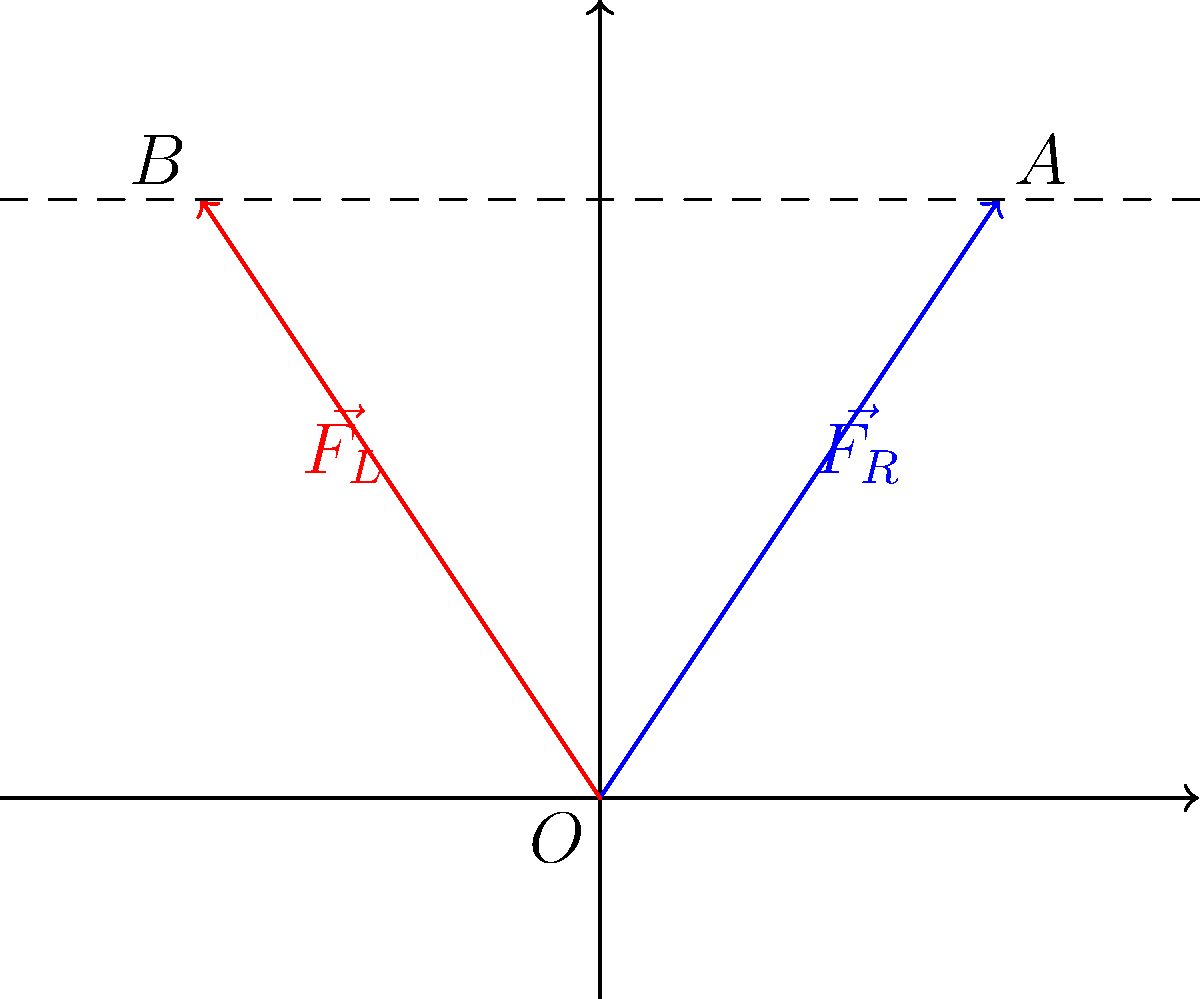In the diagram above, $\vec{F_R}$ represents the force vector for the right limb during a bilateral weightlifting movement, and $\vec{F_L}$ represents the force vector for the left limb. If $\vec{F_R}$ is reflected across the y-axis to create $\vec{F_L}$, what transformational geometry concept is demonstrated, and how does this reflection affect the magnitude and direction of the force vectors? To answer this question, let's analyze the transformational geometry concept and its effects on the force vectors:

1. Transformational Geometry Concept:
   The concept demonstrated here is reflection across the y-axis. This is a type of isometric transformation, which preserves the size and shape of the original object.

2. Effect on Magnitude:
   Reflection is an isometry, meaning it preserves distances. Therefore, the magnitude of the force vectors remains unchanged after reflection. We can observe that $|\vec{F_R}| = |\vec{F_L}|$.

3. Effect on Direction:
   Reflection across the y-axis changes the sign of the x-coordinate while keeping the y-coordinate the same. This results in:
   - The x-component of the vector changing direction (sign reversal)
   - The y-component remaining the same

4. Mathematical Representation:
   If $\vec{F_R} = (a, b)$, then $\vec{F_L} = (-a, b)$

5. Physiological Interpretation:
   In bilateral limb movements, this reflection represents the symmetry often observed between right and left limbs. The equal magnitude suggests balanced force production, while the direction change accounts for the opposite orientation of the limbs relative to the body's midline.

6. Implications for Movement Analysis:
   This geometric representation allows sports physiologists to analyze the symmetry and balance in force production between limbs during weightlifting, which is crucial for performance optimization and injury prevention.
Answer: Reflection across y-axis; preserves magnitude, reverses x-component direction. 